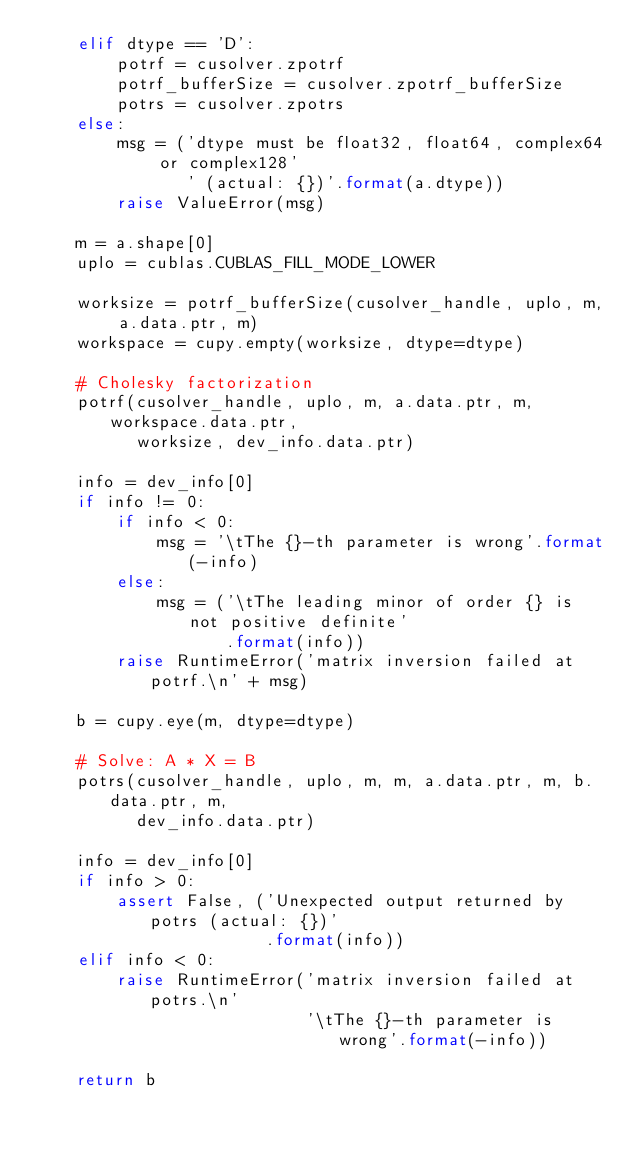<code> <loc_0><loc_0><loc_500><loc_500><_Python_>    elif dtype == 'D':
        potrf = cusolver.zpotrf
        potrf_bufferSize = cusolver.zpotrf_bufferSize
        potrs = cusolver.zpotrs
    else:
        msg = ('dtype must be float32, float64, complex64 or complex128'
               ' (actual: {})'.format(a.dtype))
        raise ValueError(msg)

    m = a.shape[0]
    uplo = cublas.CUBLAS_FILL_MODE_LOWER

    worksize = potrf_bufferSize(cusolver_handle, uplo, m, a.data.ptr, m)
    workspace = cupy.empty(worksize, dtype=dtype)

    # Cholesky factorization
    potrf(cusolver_handle, uplo, m, a.data.ptr, m, workspace.data.ptr,
          worksize, dev_info.data.ptr)

    info = dev_info[0]
    if info != 0:
        if info < 0:
            msg = '\tThe {}-th parameter is wrong'.format(-info)
        else:
            msg = ('\tThe leading minor of order {} is not positive definite'
                   .format(info))
        raise RuntimeError('matrix inversion failed at potrf.\n' + msg)

    b = cupy.eye(m, dtype=dtype)

    # Solve: A * X = B
    potrs(cusolver_handle, uplo, m, m, a.data.ptr, m, b.data.ptr, m,
          dev_info.data.ptr)

    info = dev_info[0]
    if info > 0:
        assert False, ('Unexpected output returned by potrs (actual: {})'
                       .format(info))
    elif info < 0:
        raise RuntimeError('matrix inversion failed at potrs.\n'
                           '\tThe {}-th parameter is wrong'.format(-info))

    return b
</code> 